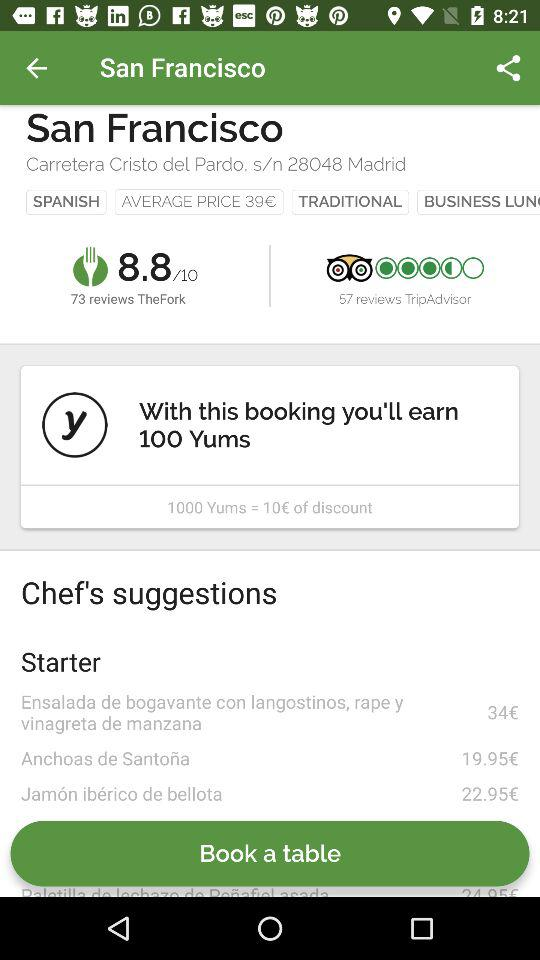How many Yums will be earned with the booking? You will earn 100 Yums with the booking. 